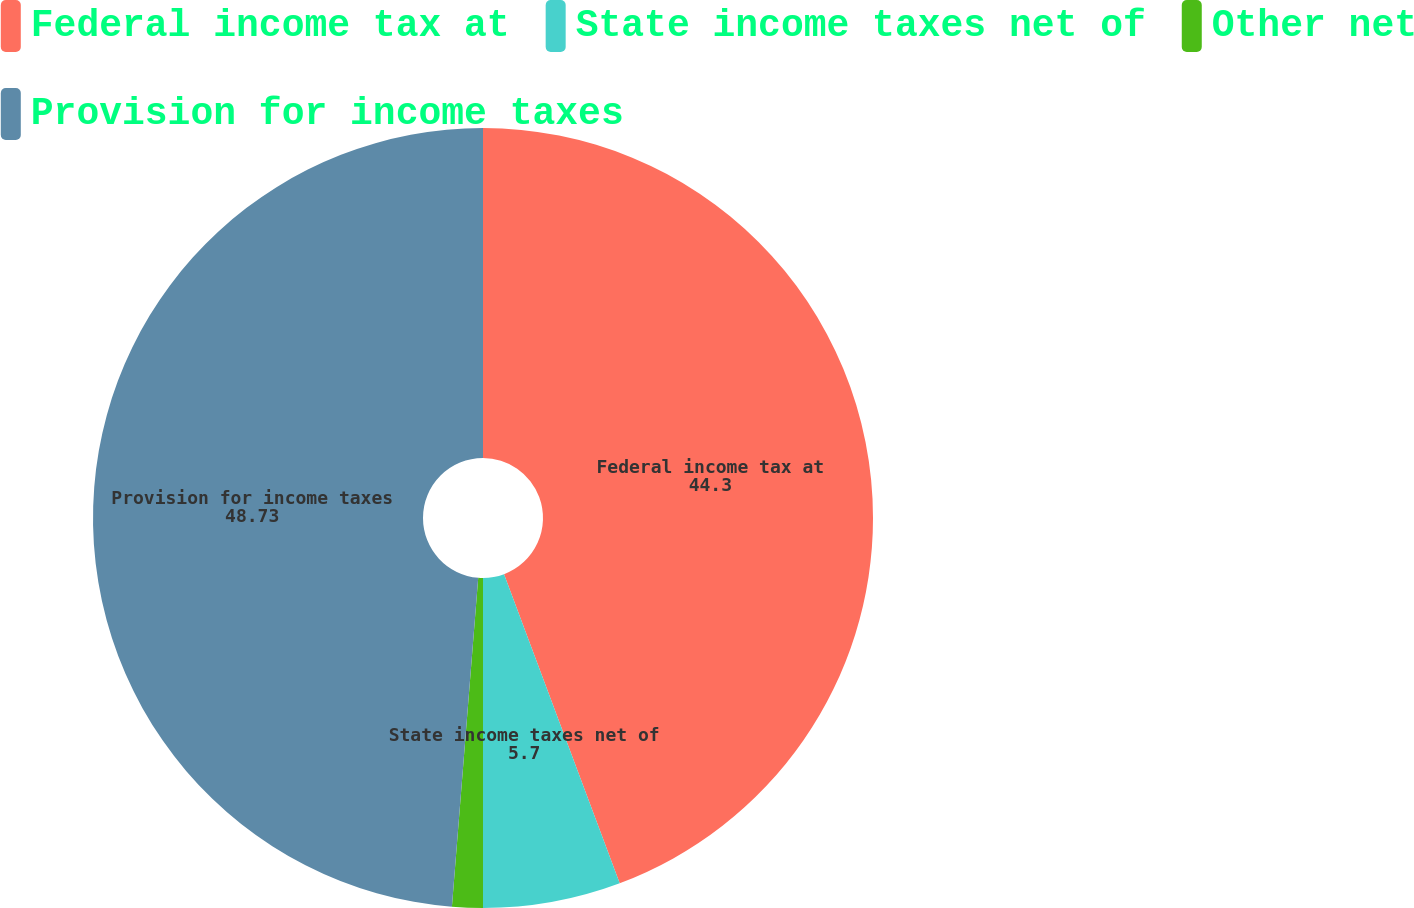<chart> <loc_0><loc_0><loc_500><loc_500><pie_chart><fcel>Federal income tax at<fcel>State income taxes net of<fcel>Other net<fcel>Provision for income taxes<nl><fcel>44.3%<fcel>5.7%<fcel>1.27%<fcel>48.73%<nl></chart> 